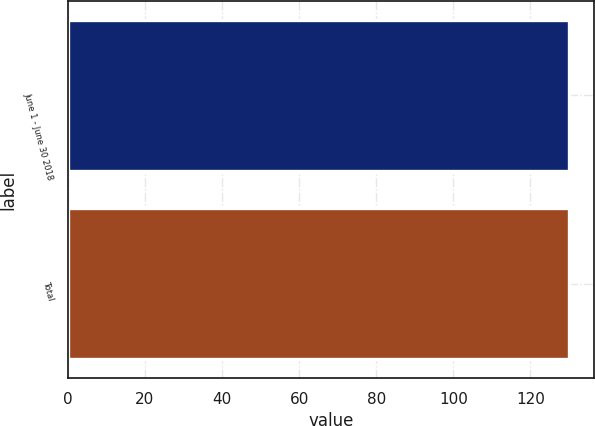<chart> <loc_0><loc_0><loc_500><loc_500><bar_chart><fcel>June 1 - June 30 2018<fcel>Total<nl><fcel>129.92<fcel>130.02<nl></chart> 